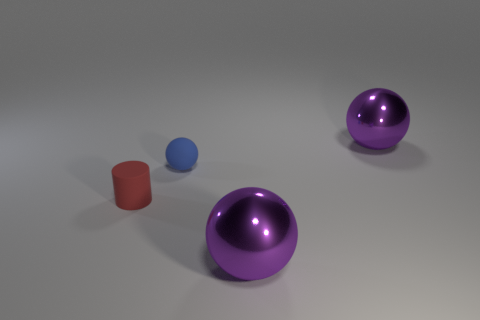Subtract all big purple spheres. How many spheres are left? 1 Subtract 1 spheres. How many spheres are left? 2 Subtract all balls. How many objects are left? 1 Subtract all purple cylinders. Subtract all yellow blocks. How many cylinders are left? 1 Subtract all gray blocks. How many gray cylinders are left? 0 Subtract all blue rubber balls. Subtract all metal objects. How many objects are left? 1 Add 1 small blue matte things. How many small blue matte things are left? 2 Add 1 big cyan rubber cylinders. How many big cyan rubber cylinders exist? 1 Add 4 rubber objects. How many objects exist? 8 Subtract all blue balls. How many balls are left? 2 